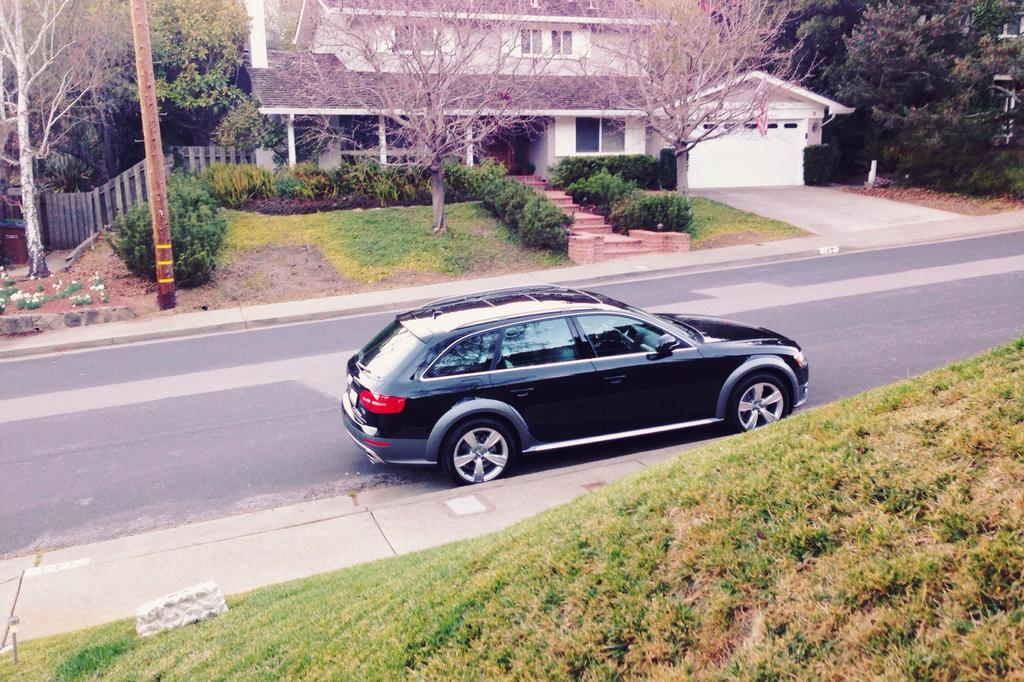What is the main subject of the image? There is a car on the road in the image. What type of natural environment is visible in the image? There is grass, trees, and plants visible in the image. What type of structures can be seen in the image? There are houses in the image. How many eggs are visible in the image? There are no eggs present in the image. What type of birds can be seen flying in the image? There are no birds visible in the image. 